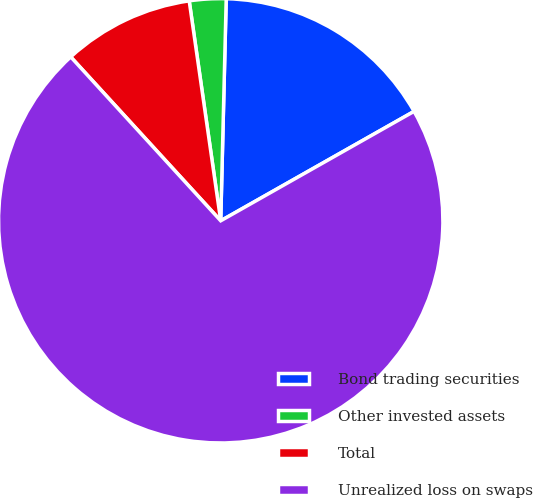Convert chart to OTSL. <chart><loc_0><loc_0><loc_500><loc_500><pie_chart><fcel>Bond trading securities<fcel>Other invested assets<fcel>Total<fcel>Unrealized loss on swaps<nl><fcel>16.41%<fcel>2.66%<fcel>9.53%<fcel>71.4%<nl></chart> 